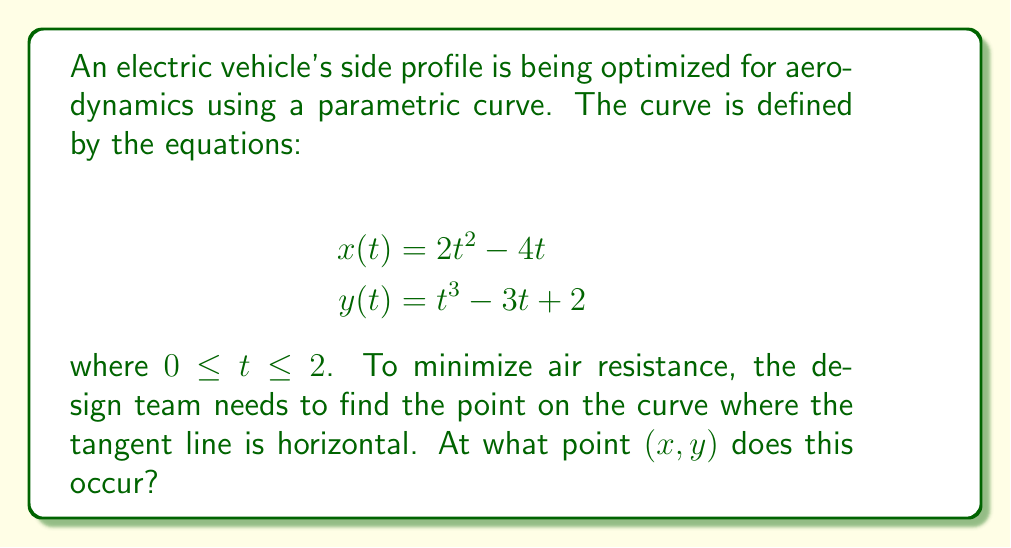Provide a solution to this math problem. To find the point where the tangent line is horizontal, we need to follow these steps:

1) A horizontal tangent line occurs when the derivative $\frac{dy}{dx} = 0$. In parametric equations, this is equivalent to $\frac{dy/dt}{dx/dt} = 0$.

2) Let's find $\frac{dx}{dt}$ and $\frac{dy}{dt}$:

   $$\frac{dx}{dt} = 4t - 4$$
   $$\frac{dy}{dt} = 3t^2 - 3$$

3) For a horizontal tangent, we need $\frac{dy}{dt} = 0$ (assuming $\frac{dx}{dt} \neq 0$):

   $$3t^2 - 3 = 0$$
   $$3(t^2 - 1) = 0$$
   $$t^2 - 1 = 0$$
   $$t^2 = 1$$
   $$t = \pm 1$$

4) Since $0 \leq t \leq 2$, we only consider $t = 1$.

5) Now, we need to find the $(x, y)$ coordinates at $t = 1$:

   $$x(1) = 2(1)^2 - 4(1) = 2 - 4 = -2$$
   $$y(1) = (1)^3 - 3(1) + 2 = 1 - 3 + 2 = 0$$

Therefore, the point where the tangent line is horizontal is $(-2, 0)$.
Answer: $(-2, 0)$ 